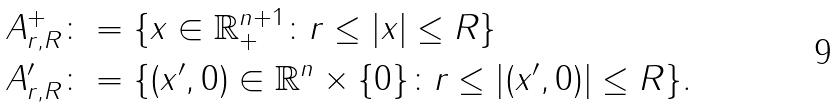<formula> <loc_0><loc_0><loc_500><loc_500>A _ { r , R } ^ { + } & \colon = \{ x \in \mathbb { R } _ { + } ^ { n + 1 } \colon r \leq | x | \leq R \} \\ A _ { r , R } ^ { \prime } & \colon = \{ ( x ^ { \prime } , 0 ) \in \mathbb { R } ^ { n } \times \{ 0 \} \colon r \leq | ( x ^ { \prime } , 0 ) | \leq R \} .</formula> 